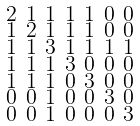<formula> <loc_0><loc_0><loc_500><loc_500>\begin{smallmatrix} 2 & 1 & 1 & 1 & 1 & 0 & 0 \\ 1 & 2 & 1 & 1 & 1 & 0 & 0 \\ 1 & 1 & 3 & 1 & 1 & 1 & 1 \\ 1 & 1 & 1 & 3 & 0 & 0 & 0 \\ 1 & 1 & 1 & 0 & 3 & 0 & 0 \\ 0 & 0 & 1 & 0 & 0 & 3 & 0 \\ 0 & 0 & 1 & 0 & 0 & 0 & 3 \end{smallmatrix}</formula> 